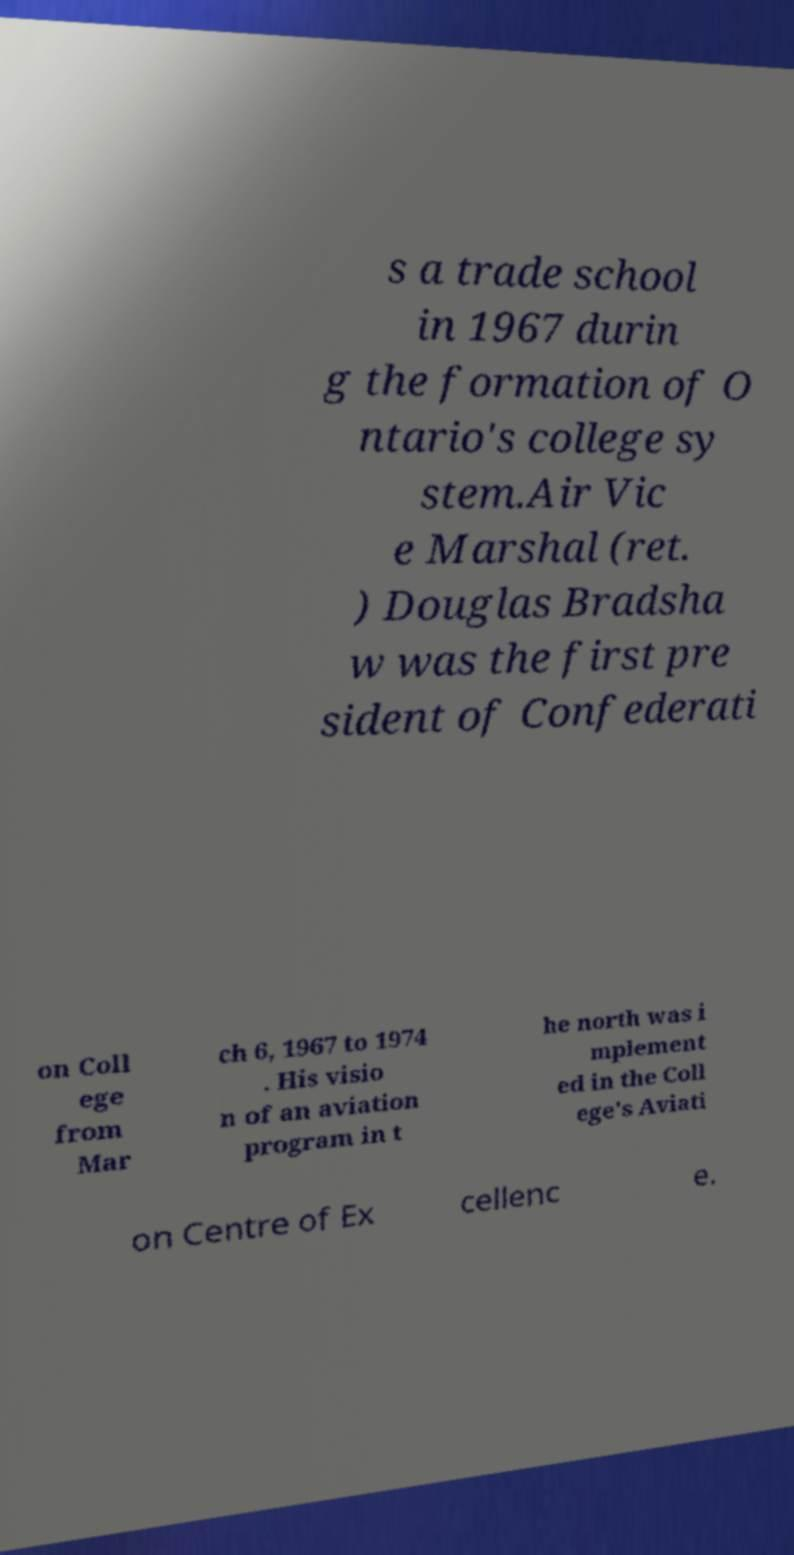Can you accurately transcribe the text from the provided image for me? s a trade school in 1967 durin g the formation of O ntario's college sy stem.Air Vic e Marshal (ret. ) Douglas Bradsha w was the first pre sident of Confederati on Coll ege from Mar ch 6, 1967 to 1974 . His visio n of an aviation program in t he north was i mplement ed in the Coll ege's Aviati on Centre of Ex cellenc e. 